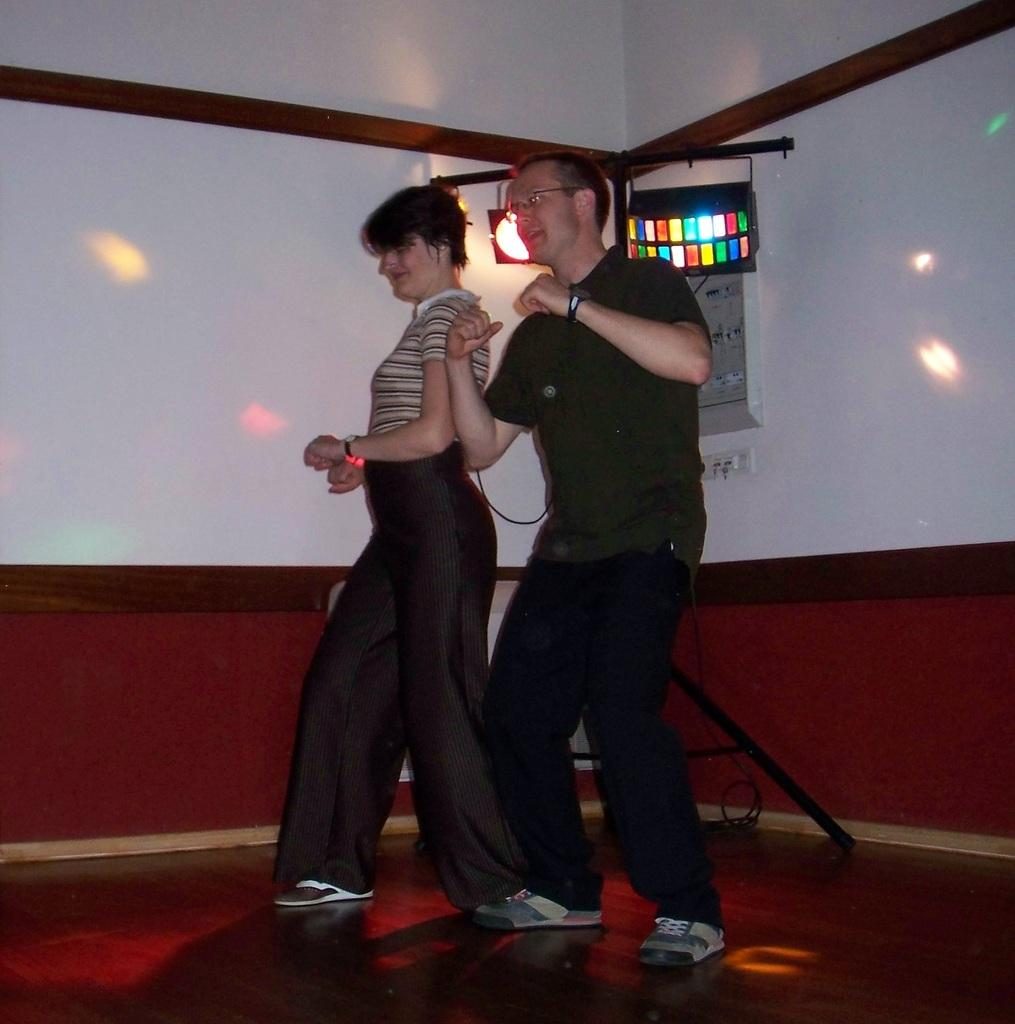Who are the people in the image? There is a man and a woman in the image. What are the man and woman doing in the image? The man and woman appear to be dancing. What can be seen in the background of the image? There are lights visible in the image. What is on the wall in the image? There is a frame on the wall in the image. What type of destruction can be seen in the image? There is no destruction present in the image; it features a man and a woman dancing with lights and a frame on the wall. 